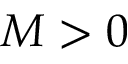Convert formula to latex. <formula><loc_0><loc_0><loc_500><loc_500>M > 0</formula> 